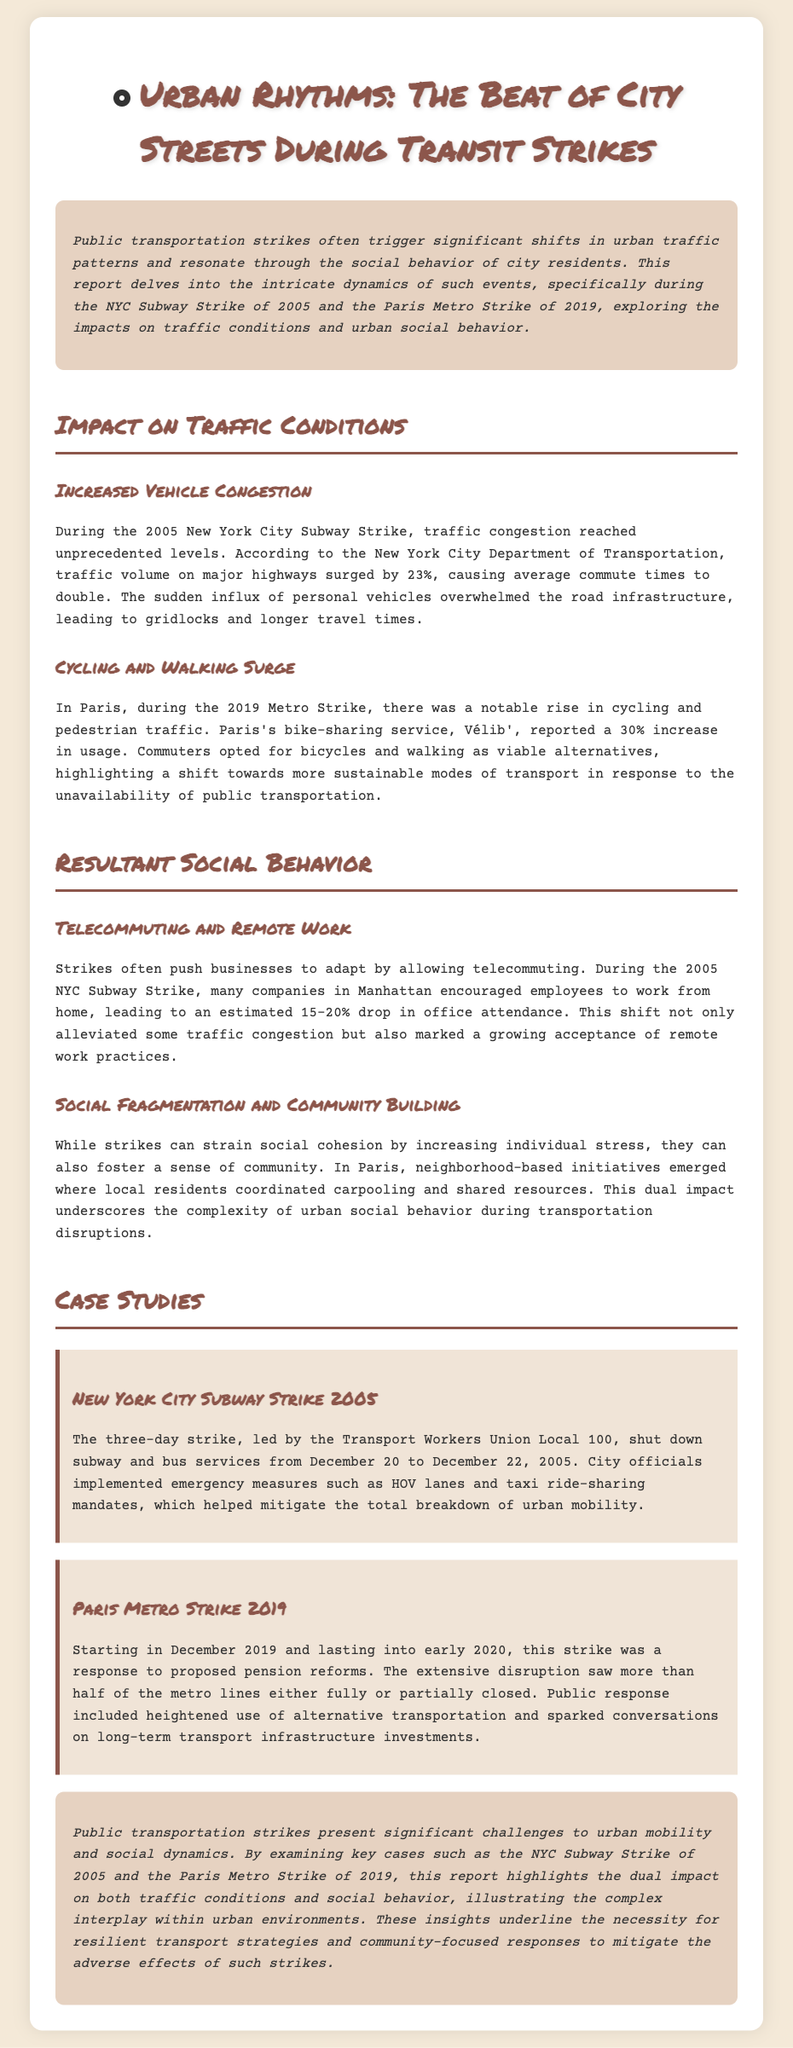What year did the NYC Subway Strike occur? The report mentions the NYC Subway Strike taking place in December 2005.
Answer: December 2005 What percentage did traffic volume surge during the NYC Subway Strike? The document states that traffic volume surged by 23% during the strike.
Answer: 23% What was the reported increase in usage of Vélib' during the Paris Metro Strike? The report highlights a 30% increase in the usage of the bike-sharing service during the strike.
Answer: 30% What shift in work practices occurred during the 2005 Subway Strike? The report notes that many companies encouraged employees to telecommute as a response to the strike.
Answer: Telecommute What type of initiatives emerged in Paris during the Metro Strike? The document discusses neighborhood-based initiatives for carpooling and resource sharing among residents.
Answer: Carpooling What was a significant impact on office attendance during the NYC Subway Strike? The estimated drop in office attendance during the strike was 15-20%.
Answer: 15-20% During which month did the Paris Metro Strike begin? The report states that the Paris Metro Strike started in December 2019.
Answer: December 2019 What emergency measures were implemented during the NYC Subway Strike? The report mentions measures like HOV lanes and taxi ride-sharing mandates to address mobility issues.
Answer: HOV lanes What long-term discussion was sparked as a result of the Paris Metro Strike? The document mentions discussions on long-term transport infrastructure investments arising from the strike.
Answer: Transport infrastructure investments 